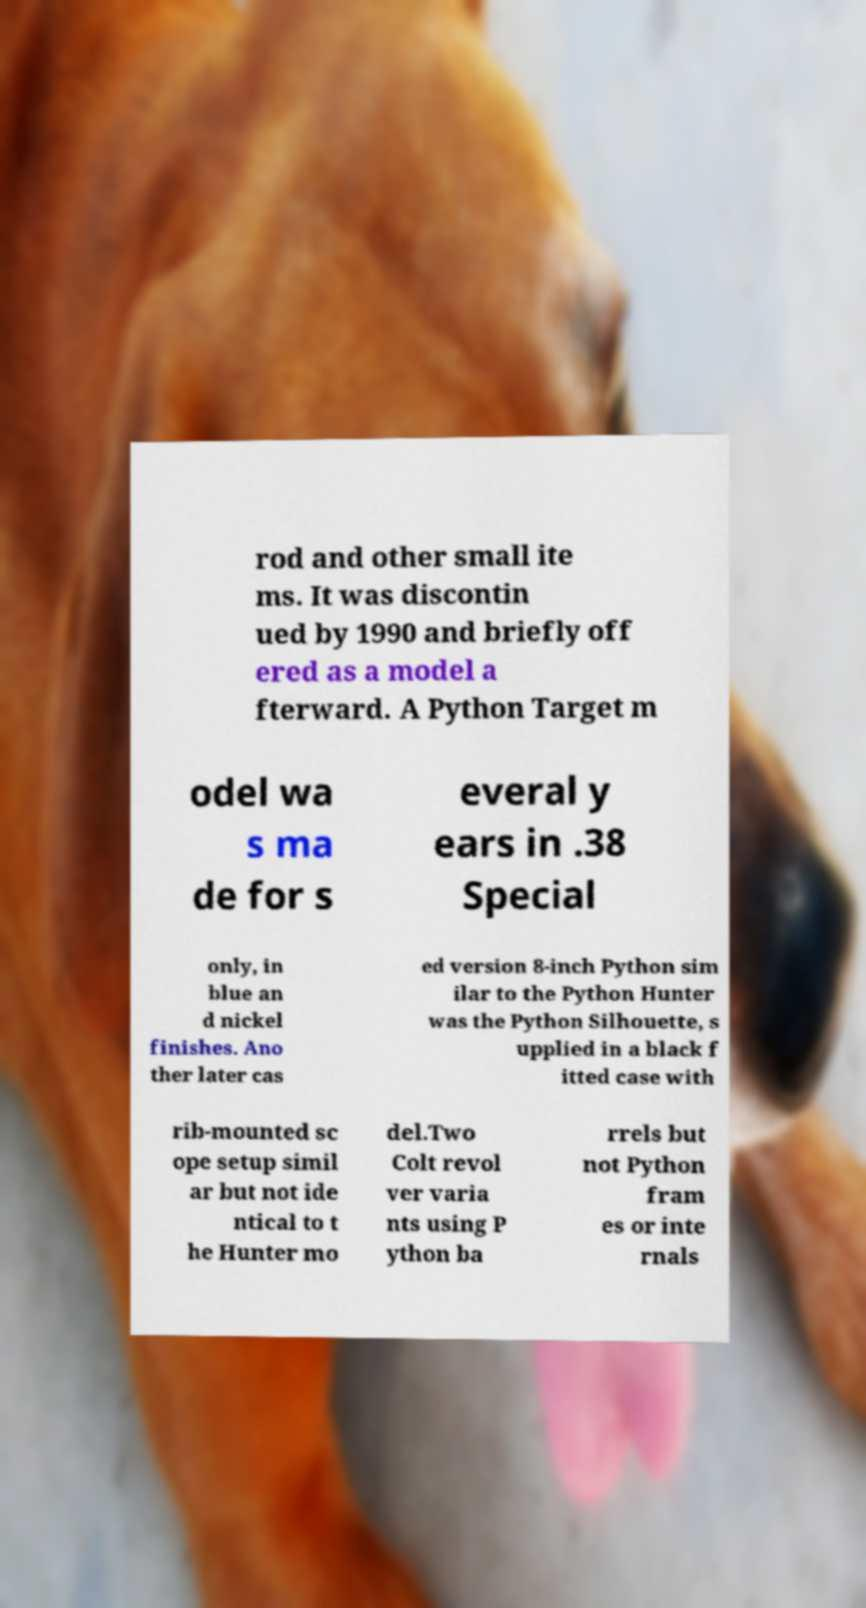Please identify and transcribe the text found in this image. rod and other small ite ms. It was discontin ued by 1990 and briefly off ered as a model a fterward. A Python Target m odel wa s ma de for s everal y ears in .38 Special only, in blue an d nickel finishes. Ano ther later cas ed version 8-inch Python sim ilar to the Python Hunter was the Python Silhouette, s upplied in a black f itted case with rib-mounted sc ope setup simil ar but not ide ntical to t he Hunter mo del.Two Colt revol ver varia nts using P ython ba rrels but not Python fram es or inte rnals 